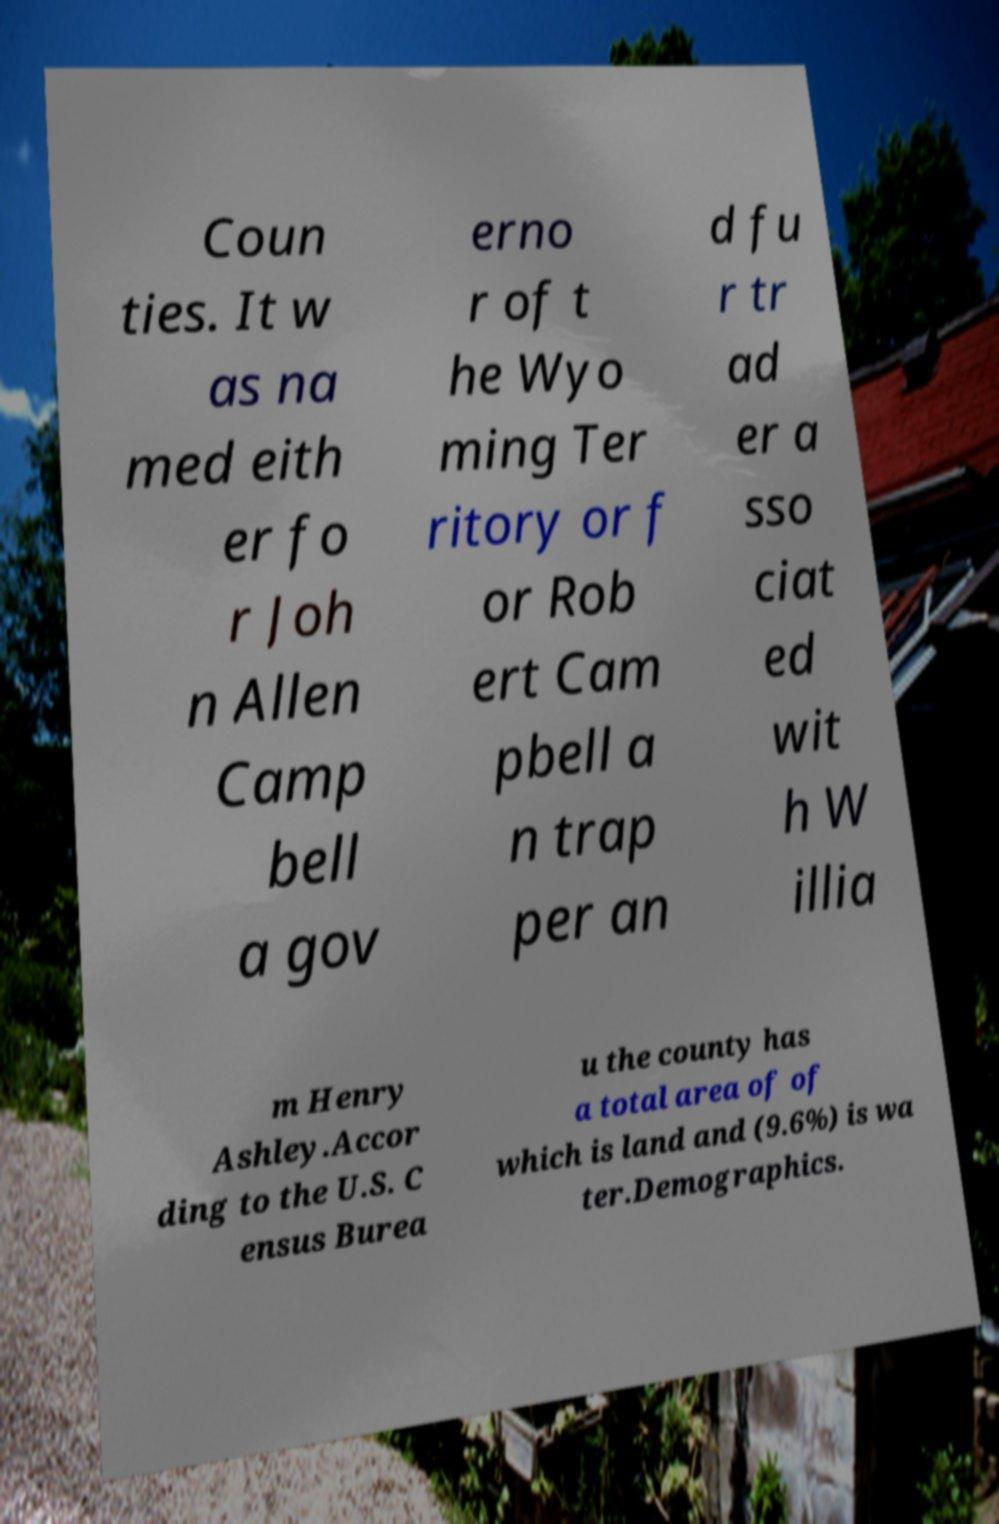Could you assist in decoding the text presented in this image and type it out clearly? Coun ties. It w as na med eith er fo r Joh n Allen Camp bell a gov erno r of t he Wyo ming Ter ritory or f or Rob ert Cam pbell a n trap per an d fu r tr ad er a sso ciat ed wit h W illia m Henry Ashley.Accor ding to the U.S. C ensus Burea u the county has a total area of of which is land and (9.6%) is wa ter.Demographics. 